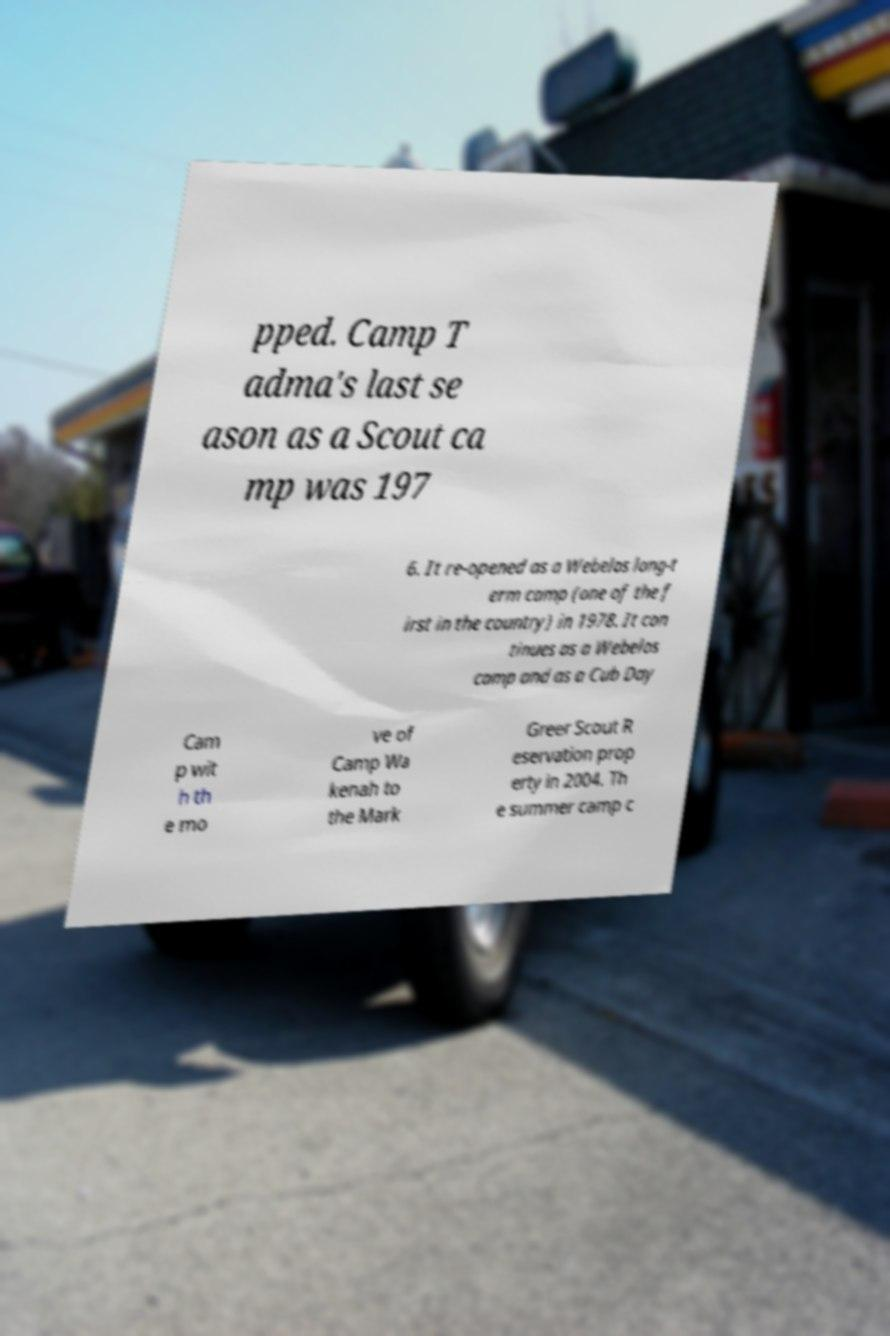There's text embedded in this image that I need extracted. Can you transcribe it verbatim? pped. Camp T adma's last se ason as a Scout ca mp was 197 6. It re-opened as a Webelos long-t erm camp (one of the f irst in the country) in 1978. It con tinues as a Webelos camp and as a Cub Day Cam p wit h th e mo ve of Camp Wa kenah to the Mark Greer Scout R eservation prop erty in 2004. Th e summer camp c 